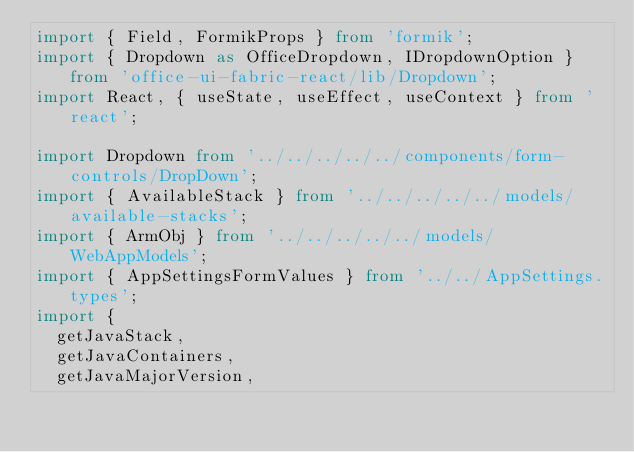Convert code to text. <code><loc_0><loc_0><loc_500><loc_500><_TypeScript_>import { Field, FormikProps } from 'formik';
import { Dropdown as OfficeDropdown, IDropdownOption } from 'office-ui-fabric-react/lib/Dropdown';
import React, { useState, useEffect, useContext } from 'react';

import Dropdown from '../../../../../components/form-controls/DropDown';
import { AvailableStack } from '../../../../../models/available-stacks';
import { ArmObj } from '../../../../../models/WebAppModels';
import { AppSettingsFormValues } from '../../AppSettings.types';
import {
  getJavaStack,
  getJavaContainers,
  getJavaMajorVersion,</code> 